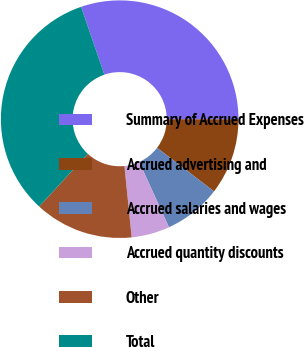Convert chart to OTSL. <chart><loc_0><loc_0><loc_500><loc_500><pie_chart><fcel>Summary of Accrued Expenses<fcel>Accrued advertising and<fcel>Accrued salaries and wages<fcel>Accrued quantity discounts<fcel>Other<fcel>Total<nl><fcel>30.29%<fcel>10.38%<fcel>7.79%<fcel>5.2%<fcel>13.46%<fcel>32.88%<nl></chart> 